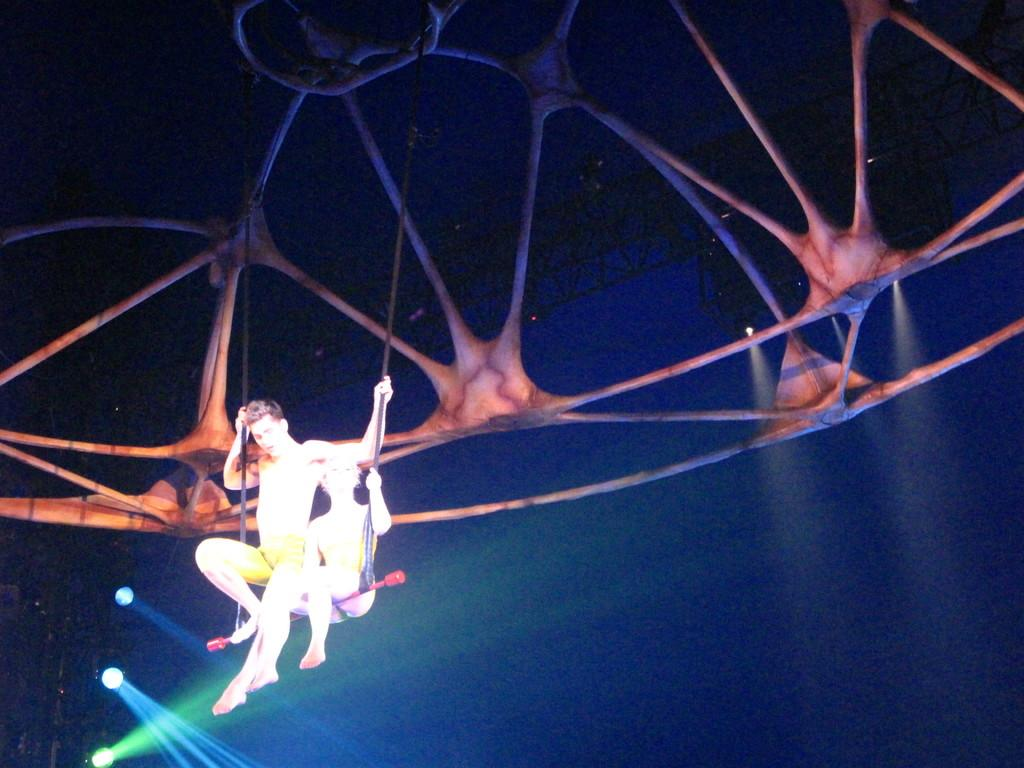How many people are in the image? There are two persons in the image. What are the persons holding in their hands? The persons are holding ropes. What can be seen in the background of the image? There are lights in the background of the image. What type of beast can be seen attacking the persons in the image? There is no beast present in the image; the persons are holding ropes. Is there any blood visible in the image? There is no blood visible in the image. 